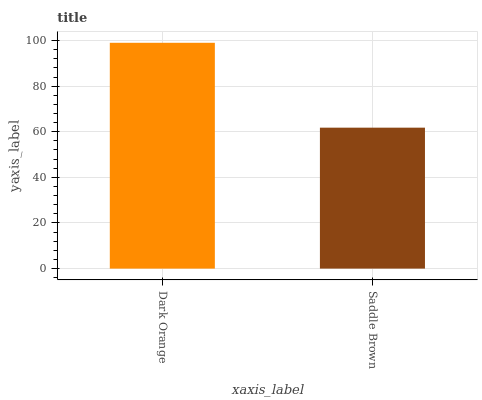Is Saddle Brown the minimum?
Answer yes or no. Yes. Is Dark Orange the maximum?
Answer yes or no. Yes. Is Saddle Brown the maximum?
Answer yes or no. No. Is Dark Orange greater than Saddle Brown?
Answer yes or no. Yes. Is Saddle Brown less than Dark Orange?
Answer yes or no. Yes. Is Saddle Brown greater than Dark Orange?
Answer yes or no. No. Is Dark Orange less than Saddle Brown?
Answer yes or no. No. Is Dark Orange the high median?
Answer yes or no. Yes. Is Saddle Brown the low median?
Answer yes or no. Yes. Is Saddle Brown the high median?
Answer yes or no. No. Is Dark Orange the low median?
Answer yes or no. No. 